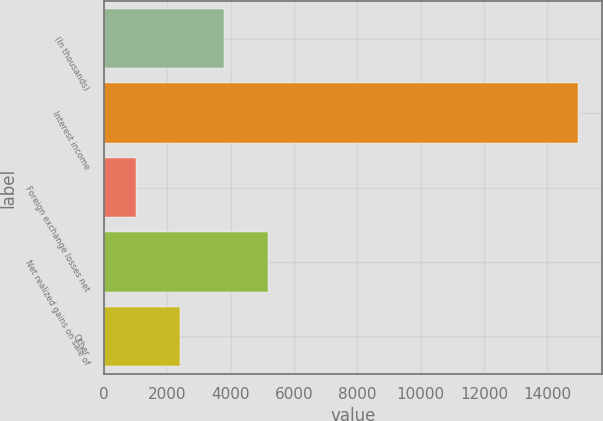<chart> <loc_0><loc_0><loc_500><loc_500><bar_chart><fcel>(In thousands)<fcel>Interest income<fcel>Foreign exchange losses net<fcel>Net realized gains on sale of<fcel>Other<nl><fcel>3796.8<fcel>14976<fcel>1002<fcel>5194.2<fcel>2399.4<nl></chart> 